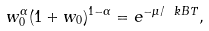<formula> <loc_0><loc_0><loc_500><loc_500>w _ { 0 } ^ { \alpha } ( 1 + w _ { 0 } ) ^ { 1 - \alpha } = e ^ { - \mu / \ k B T } ,</formula> 